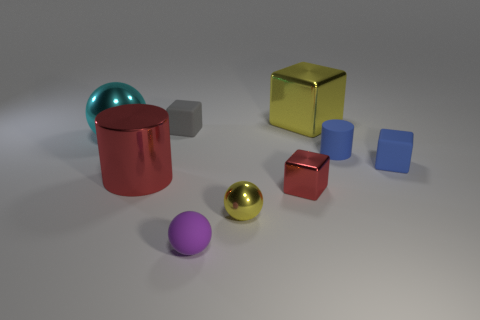Subtract all yellow shiny cubes. How many cubes are left? 3 Subtract all cubes. How many objects are left? 5 Subtract all blue cylinders. How many cylinders are left? 1 Add 1 big shiny cubes. How many objects exist? 10 Subtract 3 spheres. How many spheres are left? 0 Subtract all tiny blue rubber blocks. Subtract all large yellow blocks. How many objects are left? 7 Add 6 large blocks. How many large blocks are left? 7 Add 1 tiny green shiny balls. How many tiny green shiny balls exist? 1 Subtract 1 gray cubes. How many objects are left? 8 Subtract all red blocks. Subtract all yellow cylinders. How many blocks are left? 3 